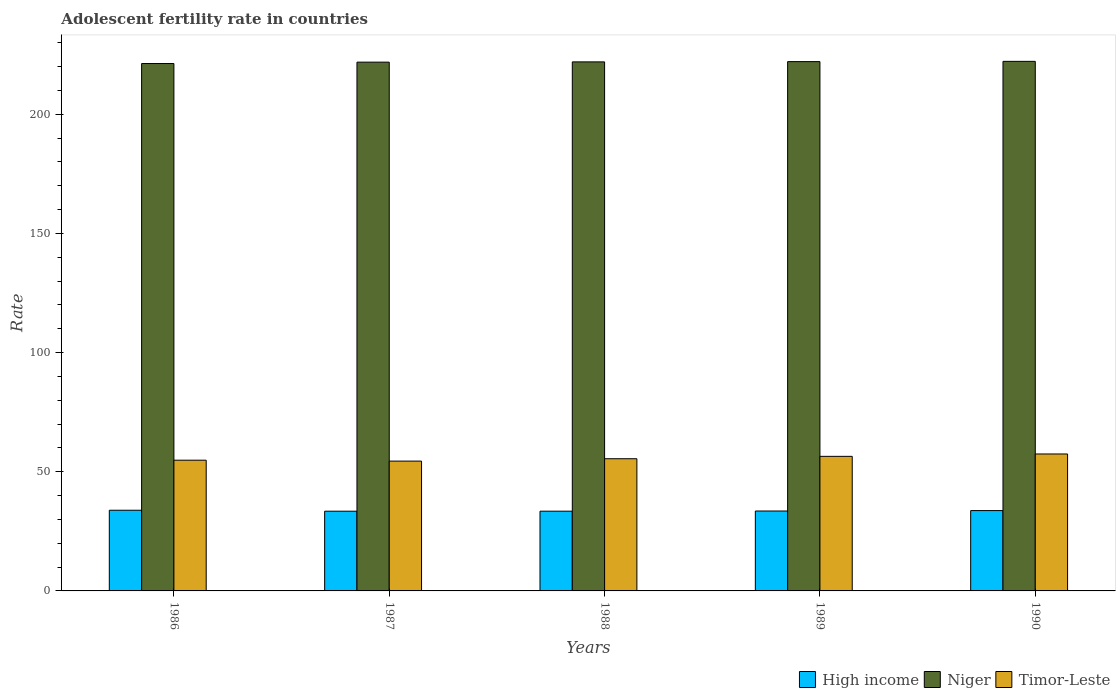How many different coloured bars are there?
Provide a succinct answer. 3. Are the number of bars per tick equal to the number of legend labels?
Keep it short and to the point. Yes. How many bars are there on the 5th tick from the left?
Provide a short and direct response. 3. What is the label of the 1st group of bars from the left?
Make the answer very short. 1986. In how many cases, is the number of bars for a given year not equal to the number of legend labels?
Ensure brevity in your answer.  0. What is the adolescent fertility rate in Niger in 1990?
Offer a very short reply. 222.21. Across all years, what is the maximum adolescent fertility rate in High income?
Offer a very short reply. 33.85. Across all years, what is the minimum adolescent fertility rate in Niger?
Ensure brevity in your answer.  221.3. In which year was the adolescent fertility rate in Niger maximum?
Provide a short and direct response. 1990. In which year was the adolescent fertility rate in High income minimum?
Ensure brevity in your answer.  1987. What is the total adolescent fertility rate in Niger in the graph?
Your answer should be very brief. 1109.49. What is the difference between the adolescent fertility rate in Timor-Leste in 1987 and that in 1990?
Give a very brief answer. -2.99. What is the difference between the adolescent fertility rate in High income in 1988 and the adolescent fertility rate in Niger in 1989?
Provide a short and direct response. -188.64. What is the average adolescent fertility rate in Niger per year?
Your response must be concise. 221.9. In the year 1989, what is the difference between the adolescent fertility rate in Timor-Leste and adolescent fertility rate in High income?
Provide a succinct answer. 22.93. In how many years, is the adolescent fertility rate in High income greater than 100?
Offer a terse response. 0. What is the ratio of the adolescent fertility rate in Niger in 1987 to that in 1989?
Keep it short and to the point. 1. What is the difference between the highest and the second highest adolescent fertility rate in High income?
Give a very brief answer. 0.14. What is the difference between the highest and the lowest adolescent fertility rate in Niger?
Make the answer very short. 0.91. In how many years, is the adolescent fertility rate in Niger greater than the average adolescent fertility rate in Niger taken over all years?
Offer a terse response. 3. Is the sum of the adolescent fertility rate in Timor-Leste in 1986 and 1989 greater than the maximum adolescent fertility rate in Niger across all years?
Provide a succinct answer. No. What does the 2nd bar from the left in 1987 represents?
Your answer should be very brief. Niger. What does the 3rd bar from the right in 1990 represents?
Give a very brief answer. High income. How many bars are there?
Provide a short and direct response. 15. Are all the bars in the graph horizontal?
Provide a succinct answer. No. What is the difference between two consecutive major ticks on the Y-axis?
Provide a short and direct response. 50. Are the values on the major ticks of Y-axis written in scientific E-notation?
Keep it short and to the point. No. How many legend labels are there?
Offer a terse response. 3. What is the title of the graph?
Your response must be concise. Adolescent fertility rate in countries. Does "Moldova" appear as one of the legend labels in the graph?
Make the answer very short. No. What is the label or title of the X-axis?
Offer a terse response. Years. What is the label or title of the Y-axis?
Make the answer very short. Rate. What is the Rate in High income in 1986?
Ensure brevity in your answer.  33.85. What is the Rate in Niger in 1986?
Make the answer very short. 221.3. What is the Rate in Timor-Leste in 1986?
Offer a terse response. 54.85. What is the Rate in High income in 1987?
Make the answer very short. 33.46. What is the Rate in Niger in 1987?
Offer a terse response. 221.88. What is the Rate of Timor-Leste in 1987?
Offer a terse response. 54.48. What is the Rate in High income in 1988?
Your answer should be very brief. 33.46. What is the Rate of Niger in 1988?
Make the answer very short. 221.99. What is the Rate of Timor-Leste in 1988?
Give a very brief answer. 55.47. What is the Rate of High income in 1989?
Keep it short and to the point. 33.54. What is the Rate of Niger in 1989?
Make the answer very short. 222.1. What is the Rate in Timor-Leste in 1989?
Provide a short and direct response. 56.47. What is the Rate of High income in 1990?
Offer a very short reply. 33.71. What is the Rate of Niger in 1990?
Offer a terse response. 222.21. What is the Rate in Timor-Leste in 1990?
Make the answer very short. 57.46. Across all years, what is the maximum Rate in High income?
Offer a very short reply. 33.85. Across all years, what is the maximum Rate in Niger?
Your response must be concise. 222.21. Across all years, what is the maximum Rate of Timor-Leste?
Your response must be concise. 57.46. Across all years, what is the minimum Rate in High income?
Provide a succinct answer. 33.46. Across all years, what is the minimum Rate of Niger?
Offer a terse response. 221.3. Across all years, what is the minimum Rate in Timor-Leste?
Offer a terse response. 54.48. What is the total Rate of High income in the graph?
Give a very brief answer. 168.02. What is the total Rate of Niger in the graph?
Provide a succinct answer. 1109.49. What is the total Rate in Timor-Leste in the graph?
Provide a succinct answer. 278.73. What is the difference between the Rate of High income in 1986 and that in 1987?
Your answer should be very brief. 0.4. What is the difference between the Rate of Niger in 1986 and that in 1987?
Provide a short and direct response. -0.58. What is the difference between the Rate in Timor-Leste in 1986 and that in 1987?
Ensure brevity in your answer.  0.38. What is the difference between the Rate of High income in 1986 and that in 1988?
Your answer should be compact. 0.39. What is the difference between the Rate of Niger in 1986 and that in 1988?
Offer a terse response. -0.69. What is the difference between the Rate in Timor-Leste in 1986 and that in 1988?
Ensure brevity in your answer.  -0.62. What is the difference between the Rate in High income in 1986 and that in 1989?
Your response must be concise. 0.32. What is the difference between the Rate of Niger in 1986 and that in 1989?
Your answer should be very brief. -0.8. What is the difference between the Rate in Timor-Leste in 1986 and that in 1989?
Offer a terse response. -1.61. What is the difference between the Rate in High income in 1986 and that in 1990?
Give a very brief answer. 0.14. What is the difference between the Rate of Niger in 1986 and that in 1990?
Offer a terse response. -0.91. What is the difference between the Rate of Timor-Leste in 1986 and that in 1990?
Provide a succinct answer. -2.61. What is the difference between the Rate of High income in 1987 and that in 1988?
Provide a succinct answer. -0.01. What is the difference between the Rate in Niger in 1987 and that in 1988?
Your response must be concise. -0.11. What is the difference between the Rate in Timor-Leste in 1987 and that in 1988?
Your answer should be compact. -1. What is the difference between the Rate of High income in 1987 and that in 1989?
Ensure brevity in your answer.  -0.08. What is the difference between the Rate of Niger in 1987 and that in 1989?
Provide a succinct answer. -0.22. What is the difference between the Rate in Timor-Leste in 1987 and that in 1989?
Offer a terse response. -1.99. What is the difference between the Rate of High income in 1987 and that in 1990?
Give a very brief answer. -0.25. What is the difference between the Rate of Niger in 1987 and that in 1990?
Offer a very short reply. -0.33. What is the difference between the Rate in Timor-Leste in 1987 and that in 1990?
Your response must be concise. -2.99. What is the difference between the Rate of High income in 1988 and that in 1989?
Make the answer very short. -0.07. What is the difference between the Rate in Niger in 1988 and that in 1989?
Offer a terse response. -0.11. What is the difference between the Rate of Timor-Leste in 1988 and that in 1989?
Give a very brief answer. -1. What is the difference between the Rate of High income in 1988 and that in 1990?
Provide a succinct answer. -0.25. What is the difference between the Rate in Niger in 1988 and that in 1990?
Offer a very short reply. -0.22. What is the difference between the Rate of Timor-Leste in 1988 and that in 1990?
Keep it short and to the point. -1.99. What is the difference between the Rate of High income in 1989 and that in 1990?
Your response must be concise. -0.17. What is the difference between the Rate in Niger in 1989 and that in 1990?
Ensure brevity in your answer.  -0.11. What is the difference between the Rate in Timor-Leste in 1989 and that in 1990?
Offer a terse response. -1. What is the difference between the Rate in High income in 1986 and the Rate in Niger in 1987?
Offer a very short reply. -188.03. What is the difference between the Rate in High income in 1986 and the Rate in Timor-Leste in 1987?
Your answer should be compact. -20.62. What is the difference between the Rate of Niger in 1986 and the Rate of Timor-Leste in 1987?
Your answer should be compact. 166.83. What is the difference between the Rate of High income in 1986 and the Rate of Niger in 1988?
Provide a succinct answer. -188.14. What is the difference between the Rate of High income in 1986 and the Rate of Timor-Leste in 1988?
Your answer should be very brief. -21.62. What is the difference between the Rate of Niger in 1986 and the Rate of Timor-Leste in 1988?
Make the answer very short. 165.83. What is the difference between the Rate in High income in 1986 and the Rate in Niger in 1989?
Your response must be concise. -188.25. What is the difference between the Rate of High income in 1986 and the Rate of Timor-Leste in 1989?
Provide a succinct answer. -22.61. What is the difference between the Rate in Niger in 1986 and the Rate in Timor-Leste in 1989?
Your response must be concise. 164.84. What is the difference between the Rate of High income in 1986 and the Rate of Niger in 1990?
Provide a short and direct response. -188.36. What is the difference between the Rate in High income in 1986 and the Rate in Timor-Leste in 1990?
Give a very brief answer. -23.61. What is the difference between the Rate in Niger in 1986 and the Rate in Timor-Leste in 1990?
Keep it short and to the point. 163.84. What is the difference between the Rate in High income in 1987 and the Rate in Niger in 1988?
Provide a succinct answer. -188.54. What is the difference between the Rate in High income in 1987 and the Rate in Timor-Leste in 1988?
Offer a very short reply. -22.02. What is the difference between the Rate in Niger in 1987 and the Rate in Timor-Leste in 1988?
Keep it short and to the point. 166.41. What is the difference between the Rate in High income in 1987 and the Rate in Niger in 1989?
Your response must be concise. -188.65. What is the difference between the Rate of High income in 1987 and the Rate of Timor-Leste in 1989?
Your response must be concise. -23.01. What is the difference between the Rate in Niger in 1987 and the Rate in Timor-Leste in 1989?
Keep it short and to the point. 165.41. What is the difference between the Rate in High income in 1987 and the Rate in Niger in 1990?
Your answer should be very brief. -188.76. What is the difference between the Rate of High income in 1987 and the Rate of Timor-Leste in 1990?
Make the answer very short. -24.01. What is the difference between the Rate of Niger in 1987 and the Rate of Timor-Leste in 1990?
Provide a short and direct response. 164.42. What is the difference between the Rate of High income in 1988 and the Rate of Niger in 1989?
Offer a very short reply. -188.64. What is the difference between the Rate in High income in 1988 and the Rate in Timor-Leste in 1989?
Provide a succinct answer. -23. What is the difference between the Rate in Niger in 1988 and the Rate in Timor-Leste in 1989?
Give a very brief answer. 165.52. What is the difference between the Rate in High income in 1988 and the Rate in Niger in 1990?
Provide a succinct answer. -188.75. What is the difference between the Rate of High income in 1988 and the Rate of Timor-Leste in 1990?
Make the answer very short. -24. What is the difference between the Rate of Niger in 1988 and the Rate of Timor-Leste in 1990?
Your response must be concise. 164.53. What is the difference between the Rate in High income in 1989 and the Rate in Niger in 1990?
Your answer should be compact. -188.68. What is the difference between the Rate in High income in 1989 and the Rate in Timor-Leste in 1990?
Make the answer very short. -23.93. What is the difference between the Rate of Niger in 1989 and the Rate of Timor-Leste in 1990?
Keep it short and to the point. 164.64. What is the average Rate in High income per year?
Offer a very short reply. 33.6. What is the average Rate in Niger per year?
Your response must be concise. 221.9. What is the average Rate in Timor-Leste per year?
Offer a terse response. 55.75. In the year 1986, what is the difference between the Rate in High income and Rate in Niger?
Your answer should be compact. -187.45. In the year 1986, what is the difference between the Rate of High income and Rate of Timor-Leste?
Your answer should be very brief. -21. In the year 1986, what is the difference between the Rate of Niger and Rate of Timor-Leste?
Your answer should be compact. 166.45. In the year 1987, what is the difference between the Rate of High income and Rate of Niger?
Your answer should be very brief. -188.42. In the year 1987, what is the difference between the Rate in High income and Rate in Timor-Leste?
Offer a terse response. -21.02. In the year 1987, what is the difference between the Rate of Niger and Rate of Timor-Leste?
Offer a terse response. 167.4. In the year 1988, what is the difference between the Rate in High income and Rate in Niger?
Provide a short and direct response. -188.53. In the year 1988, what is the difference between the Rate in High income and Rate in Timor-Leste?
Provide a succinct answer. -22.01. In the year 1988, what is the difference between the Rate in Niger and Rate in Timor-Leste?
Give a very brief answer. 166.52. In the year 1989, what is the difference between the Rate of High income and Rate of Niger?
Your answer should be very brief. -188.57. In the year 1989, what is the difference between the Rate of High income and Rate of Timor-Leste?
Offer a terse response. -22.93. In the year 1989, what is the difference between the Rate of Niger and Rate of Timor-Leste?
Ensure brevity in your answer.  165.63. In the year 1990, what is the difference between the Rate of High income and Rate of Niger?
Your response must be concise. -188.5. In the year 1990, what is the difference between the Rate of High income and Rate of Timor-Leste?
Provide a succinct answer. -23.75. In the year 1990, what is the difference between the Rate of Niger and Rate of Timor-Leste?
Offer a very short reply. 164.75. What is the ratio of the Rate in High income in 1986 to that in 1987?
Keep it short and to the point. 1.01. What is the ratio of the Rate of Niger in 1986 to that in 1987?
Offer a very short reply. 1. What is the ratio of the Rate of High income in 1986 to that in 1988?
Offer a terse response. 1.01. What is the ratio of the Rate of Timor-Leste in 1986 to that in 1988?
Offer a very short reply. 0.99. What is the ratio of the Rate of High income in 1986 to that in 1989?
Your answer should be compact. 1.01. What is the ratio of the Rate of Timor-Leste in 1986 to that in 1989?
Provide a succinct answer. 0.97. What is the ratio of the Rate in High income in 1986 to that in 1990?
Your response must be concise. 1. What is the ratio of the Rate of Timor-Leste in 1986 to that in 1990?
Your answer should be compact. 0.95. What is the ratio of the Rate of High income in 1987 to that in 1988?
Ensure brevity in your answer.  1. What is the ratio of the Rate of Timor-Leste in 1987 to that in 1988?
Make the answer very short. 0.98. What is the ratio of the Rate in High income in 1987 to that in 1989?
Your answer should be compact. 1. What is the ratio of the Rate of Timor-Leste in 1987 to that in 1989?
Offer a terse response. 0.96. What is the ratio of the Rate in Niger in 1987 to that in 1990?
Your answer should be very brief. 1. What is the ratio of the Rate in Timor-Leste in 1987 to that in 1990?
Give a very brief answer. 0.95. What is the ratio of the Rate of High income in 1988 to that in 1989?
Give a very brief answer. 1. What is the ratio of the Rate in Niger in 1988 to that in 1989?
Your response must be concise. 1. What is the ratio of the Rate of Timor-Leste in 1988 to that in 1989?
Your answer should be very brief. 0.98. What is the ratio of the Rate of High income in 1988 to that in 1990?
Make the answer very short. 0.99. What is the ratio of the Rate of Timor-Leste in 1988 to that in 1990?
Provide a short and direct response. 0.97. What is the ratio of the Rate in Niger in 1989 to that in 1990?
Your answer should be compact. 1. What is the ratio of the Rate of Timor-Leste in 1989 to that in 1990?
Keep it short and to the point. 0.98. What is the difference between the highest and the second highest Rate of High income?
Give a very brief answer. 0.14. What is the difference between the highest and the second highest Rate of Niger?
Ensure brevity in your answer.  0.11. What is the difference between the highest and the second highest Rate in Timor-Leste?
Ensure brevity in your answer.  1. What is the difference between the highest and the lowest Rate in High income?
Make the answer very short. 0.4. What is the difference between the highest and the lowest Rate of Niger?
Your answer should be compact. 0.91. What is the difference between the highest and the lowest Rate of Timor-Leste?
Provide a short and direct response. 2.99. 